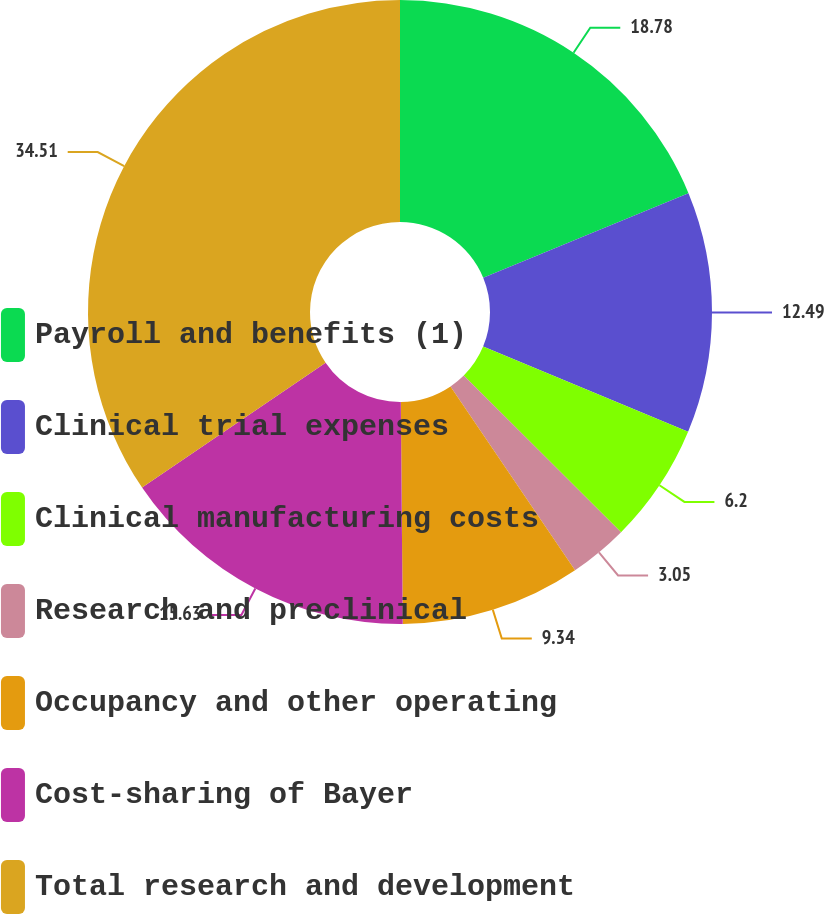<chart> <loc_0><loc_0><loc_500><loc_500><pie_chart><fcel>Payroll and benefits (1)<fcel>Clinical trial expenses<fcel>Clinical manufacturing costs<fcel>Research and preclinical<fcel>Occupancy and other operating<fcel>Cost-sharing of Bayer<fcel>Total research and development<nl><fcel>18.78%<fcel>12.49%<fcel>6.2%<fcel>3.05%<fcel>9.34%<fcel>15.63%<fcel>34.51%<nl></chart> 